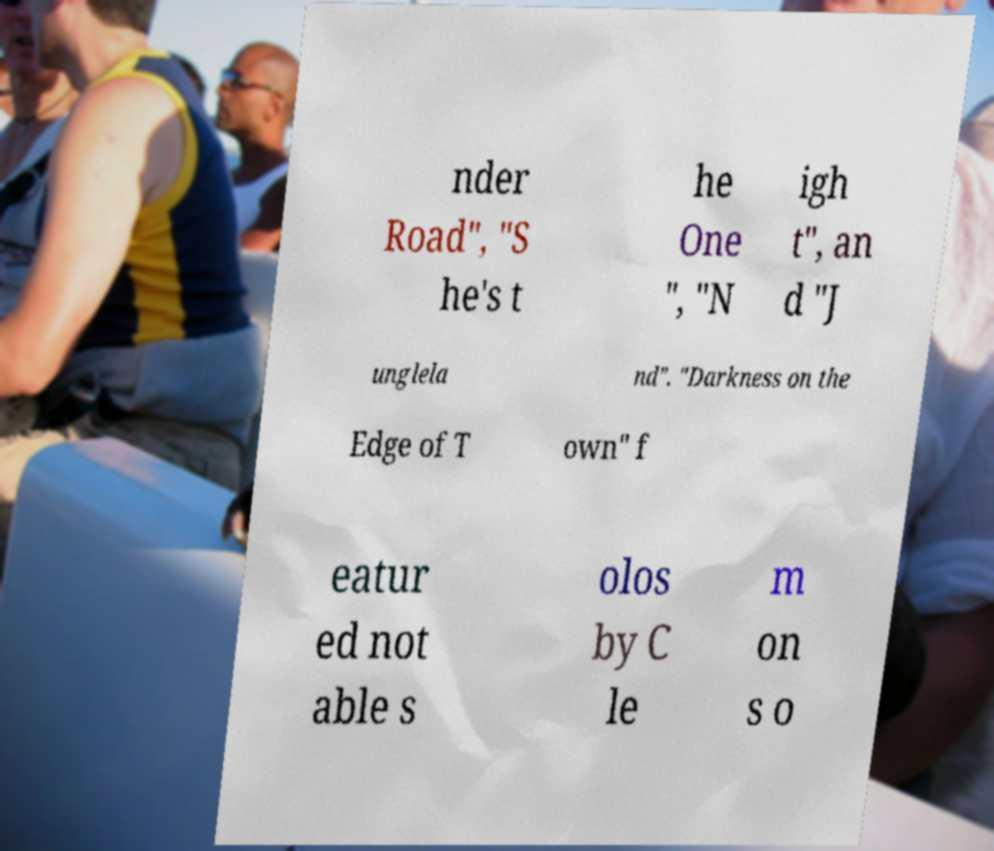What messages or text are displayed in this image? I need them in a readable, typed format. nder Road", "S he's t he One ", "N igh t", an d "J unglela nd". "Darkness on the Edge of T own" f eatur ed not able s olos by C le m on s o 